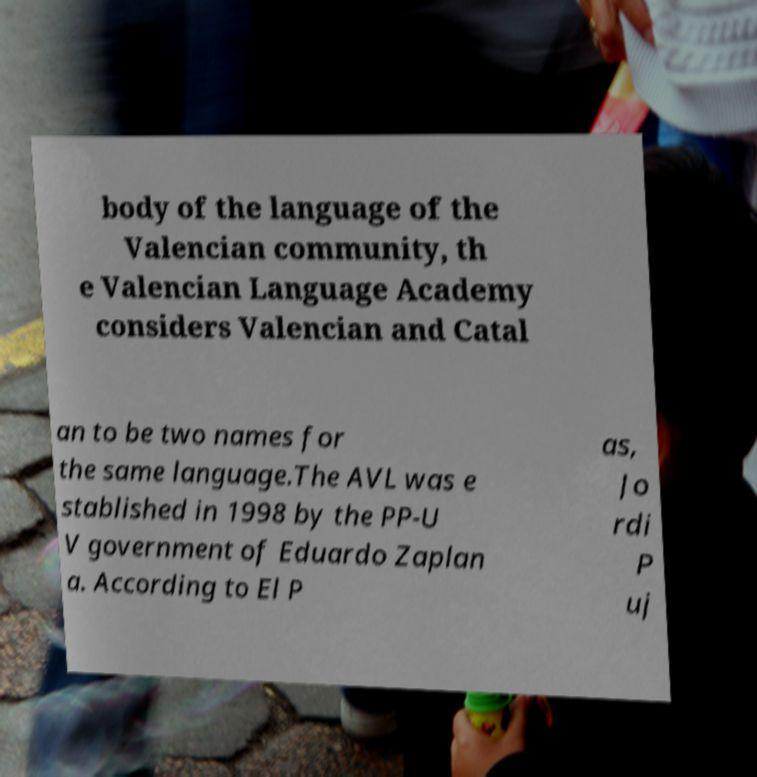Can you accurately transcribe the text from the provided image for me? body of the language of the Valencian community, th e Valencian Language Academy considers Valencian and Catal an to be two names for the same language.The AVL was e stablished in 1998 by the PP-U V government of Eduardo Zaplan a. According to El P as, Jo rdi P uj 